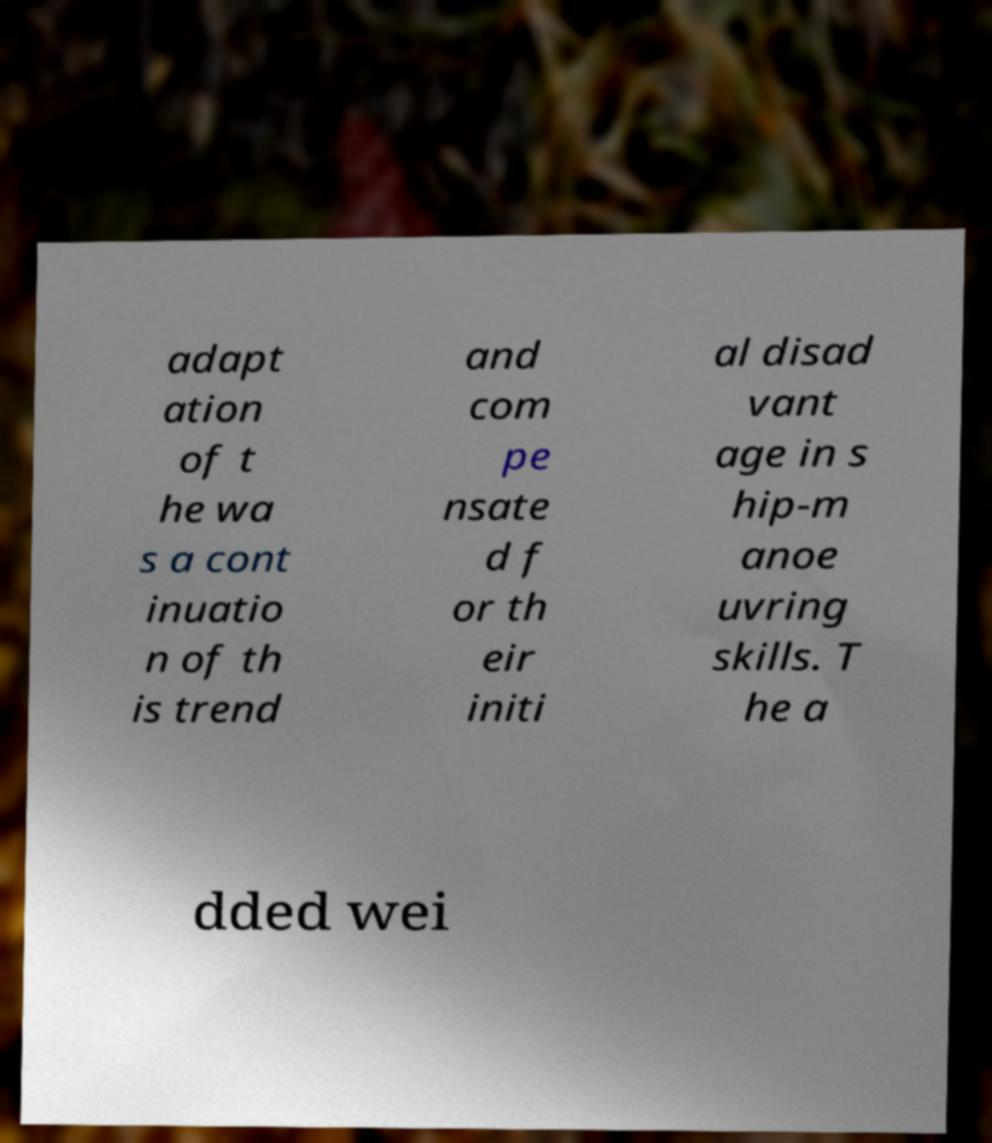Can you accurately transcribe the text from the provided image for me? adapt ation of t he wa s a cont inuatio n of th is trend and com pe nsate d f or th eir initi al disad vant age in s hip-m anoe uvring skills. T he a dded wei 